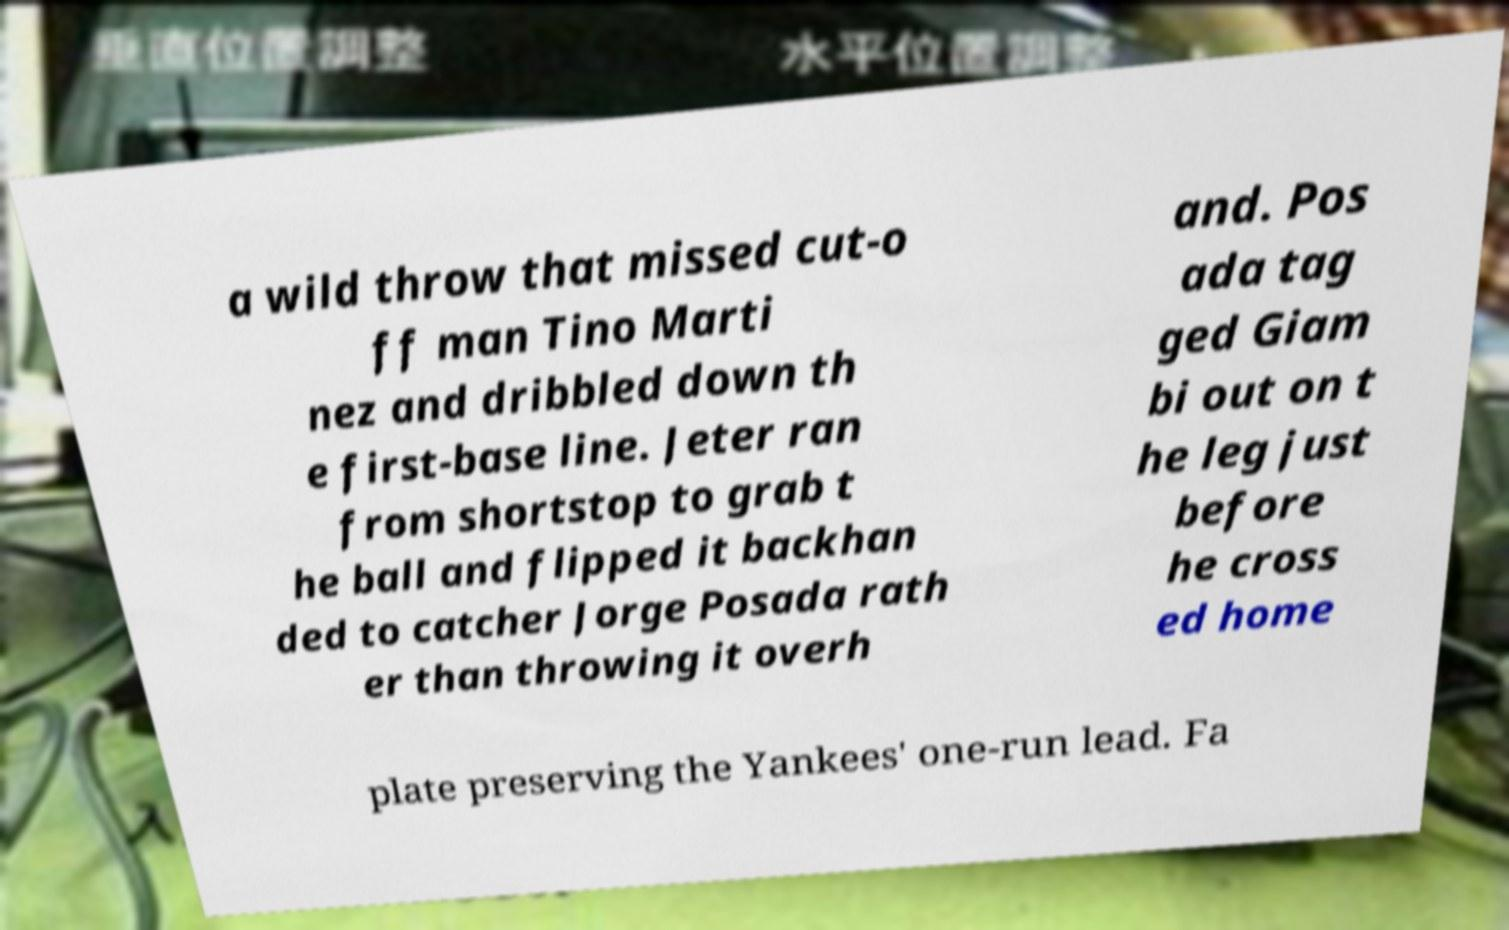Can you accurately transcribe the text from the provided image for me? a wild throw that missed cut-o ff man Tino Marti nez and dribbled down th e first-base line. Jeter ran from shortstop to grab t he ball and flipped it backhan ded to catcher Jorge Posada rath er than throwing it overh and. Pos ada tag ged Giam bi out on t he leg just before he cross ed home plate preserving the Yankees' one-run lead. Fa 